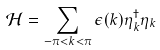Convert formula to latex. <formula><loc_0><loc_0><loc_500><loc_500>\mathcal { H } = \sum _ { - \pi < k < \pi } \epsilon ( k ) \eta _ { k } ^ { \dag } \eta _ { k }</formula> 